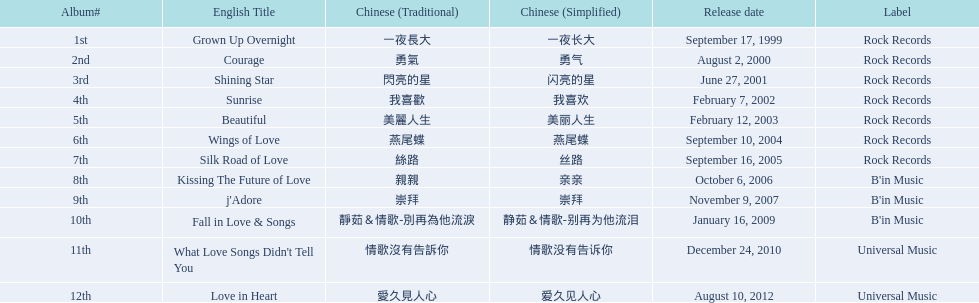What label was she working with before universal music? B'in Music. 